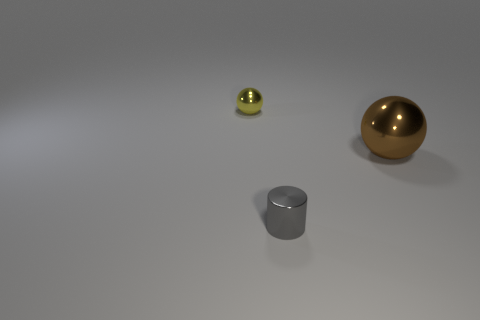Add 3 small things. How many objects exist? 6 Subtract all cylinders. How many objects are left? 2 Subtract all yellow metal balls. Subtract all red metallic balls. How many objects are left? 2 Add 3 tiny shiny balls. How many tiny shiny balls are left? 4 Add 2 objects. How many objects exist? 5 Subtract 0 purple cylinders. How many objects are left? 3 